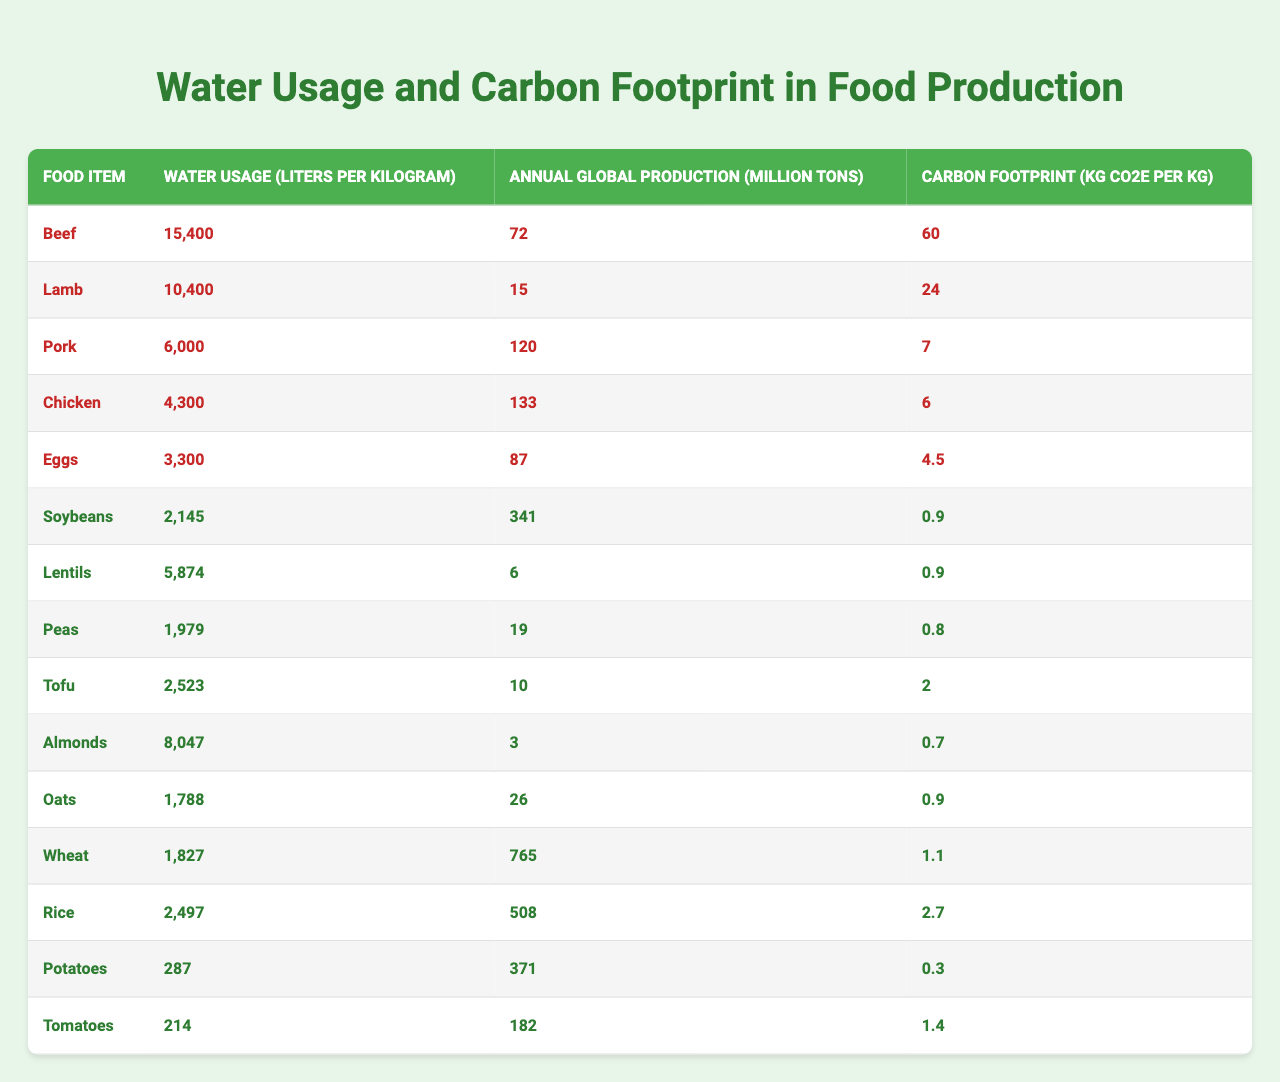What is the water usage for chicken production? The table indicates that chicken production requires 4,300 liters of water per kilogram.
Answer: 4,300 liters Which food item has the highest carbon footprint? Looking at the carbon footprint values, beef has the highest carbon footprint at 60 kg CO2e per kg.
Answer: Beef What is the total annual global production of plant-based foods listed? The relevant plant-based foods and their production figures are: Soybeans (341), Lentils (6), Peas (19), Tofu (10), Almonds (3), Oats (26), Wheat (765), Rice (508), Potatoes (371), and Tomatoes (182). Summing these yields 341 + 6 + 19 + 10 + 3 + 26 + 765 + 508 + 371 + 182 = 1731 million tons.
Answer: 1,731 million tons Is the water usage for tofu higher than for lentils? The table shows that tofu requires 2,523 liters of water per kilogram, while lentils require 5,874 liters. Since 5,874 is greater than 2,523, the statement is false.
Answer: No Which food items use less than 3,000 liters of water per kilogram? By examining the water usage values, potatoes (287) and tomatoes (214) are the only items below 3,000 liters.
Answer: Potatoes and Tomatoes What is the average carbon footprint of the plant-based foods listed? The carbon footprints of plant-based foods are: Soybeans (0.9), Lentils (0.9), Peas (0.8), Tofu (2), Almonds (0.7), Oats (0.9), Wheat (1.1), Rice (2.7), Potatoes (0.3), Tomatoes (1.4). Their total is 0.9 + 0.9 + 0.8 + 2 + 0.7 + 0.9 + 1.1 + 2.7 + 0.3 + 1.4 = 12.9. There are 10 items, so the average is 12.9 / 10 = 1.29.
Answer: 1.29 kg CO2e How much more water is required for beef compared to tofu? Beef requires 15,400 liters and tofu requires 2,523 liters. The difference is 15,400 - 2,523 = 12,877 liters.
Answer: 12,877 liters What food item has the lowest water usage? The lowest water usage in the table is for tomatoes at 214 liters per kilogram.
Answer: Tomatoes Are eggs less carbon-intensive than chicken? Eggs have a carbon footprint of 4.5 kg CO2e per kg while chicken has a carbon footprint of 6 kg CO2e per kg. Since 4.5 is less than 6, the statement is true.
Answer: Yes What is the total carbon footprint of the animal-based foods listed? The animal-based foods and their carbon footprints are: Beef (60), Lamb (24), Pork (7), Chicken (6), Eggs (4.5). Summing these gives 60 + 24 + 7 + 6 + 4.5 = 101.5 kg CO2e.
Answer: 101.5 kg CO2e 